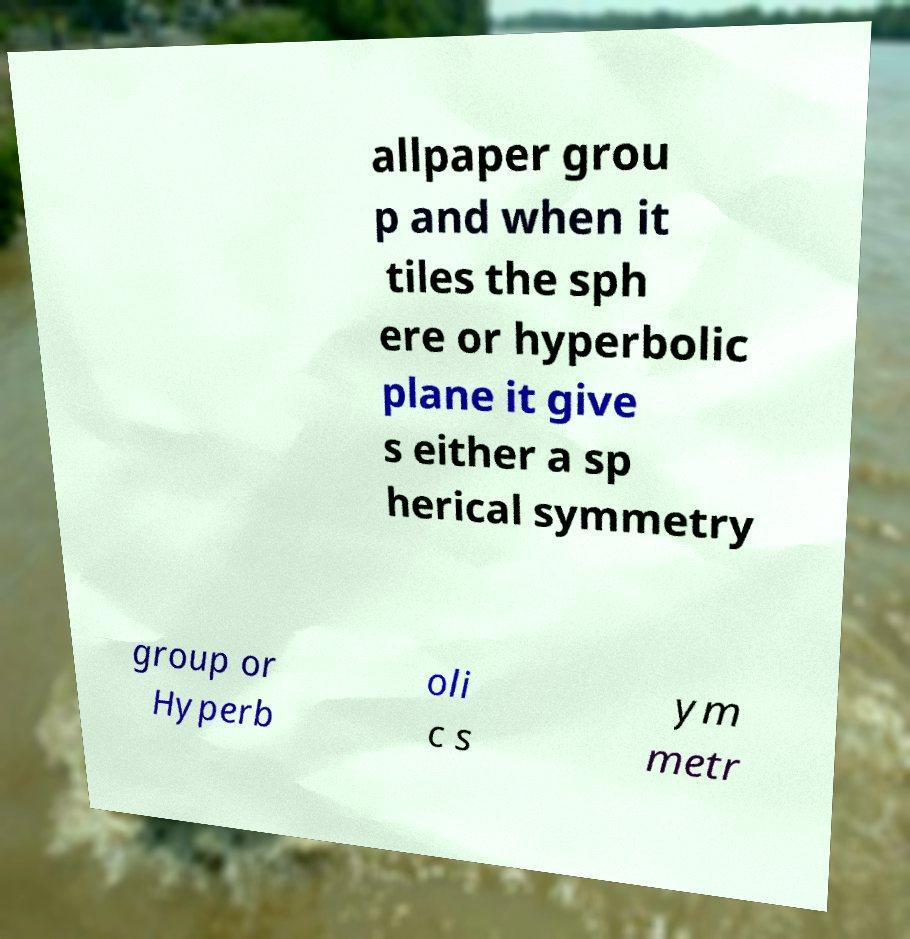Can you accurately transcribe the text from the provided image for me? allpaper grou p and when it tiles the sph ere or hyperbolic plane it give s either a sp herical symmetry group or Hyperb oli c s ym metr 